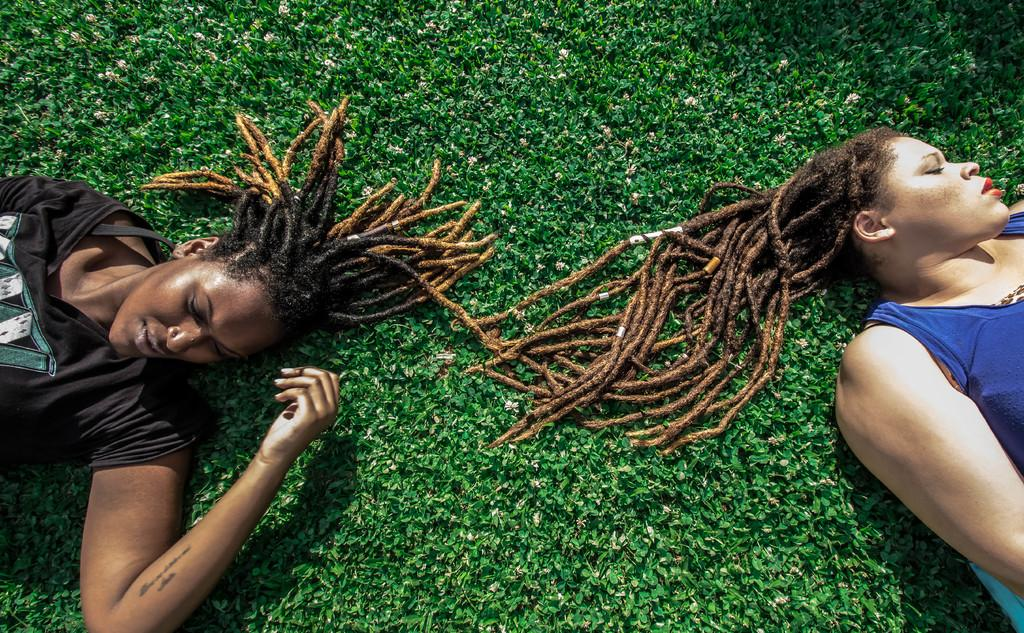How many people are in the image? There are two people in the image. What are the two people doing in the image? The two people are lying on the ground. What type of clover can be seen growing near the people in the image? There is no clover visible in the image. What is the value of the train ticket for the people in the image? There is no train or train ticket present in the image. 